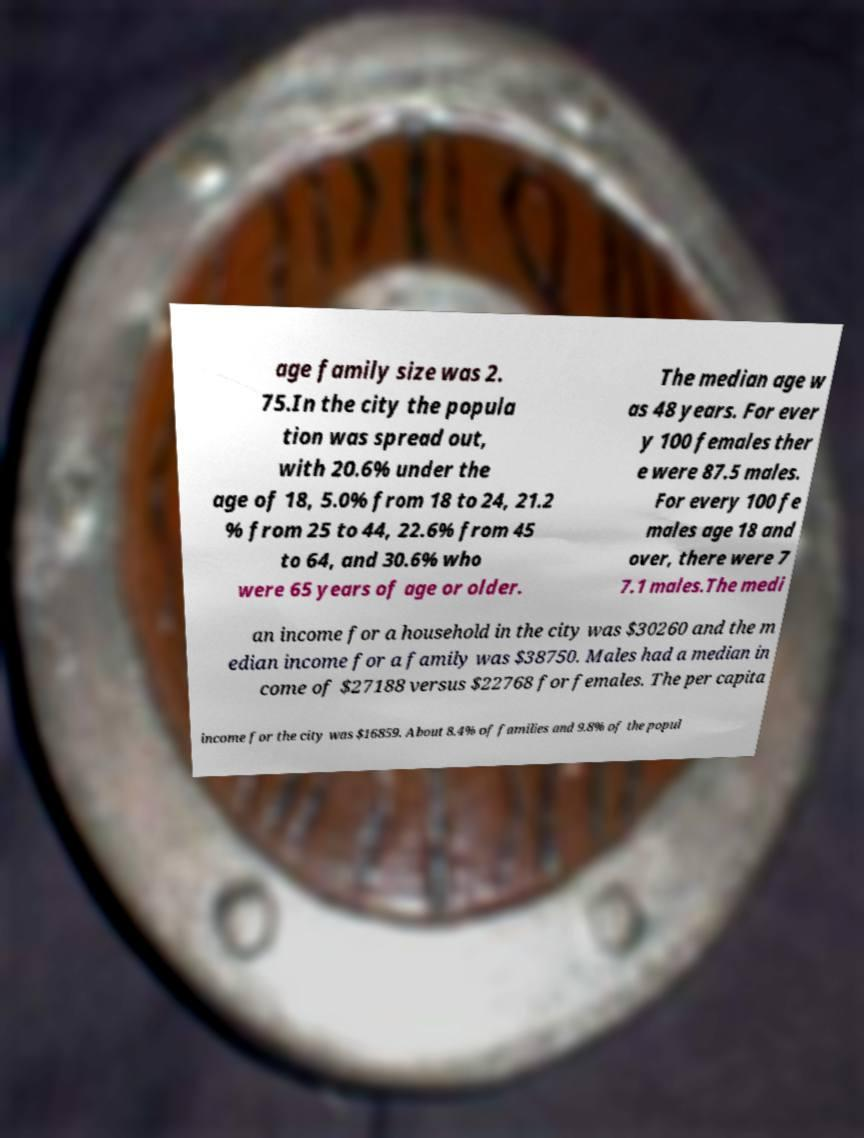Could you assist in decoding the text presented in this image and type it out clearly? age family size was 2. 75.In the city the popula tion was spread out, with 20.6% under the age of 18, 5.0% from 18 to 24, 21.2 % from 25 to 44, 22.6% from 45 to 64, and 30.6% who were 65 years of age or older. The median age w as 48 years. For ever y 100 females ther e were 87.5 males. For every 100 fe males age 18 and over, there were 7 7.1 males.The medi an income for a household in the city was $30260 and the m edian income for a family was $38750. Males had a median in come of $27188 versus $22768 for females. The per capita income for the city was $16859. About 8.4% of families and 9.8% of the popul 